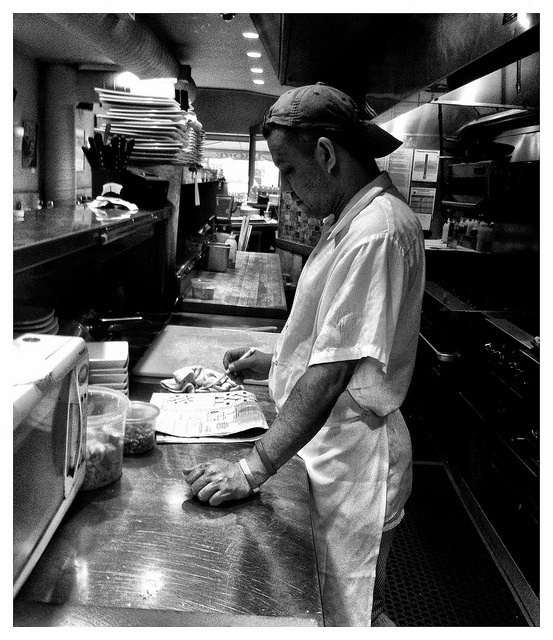Describe the objects in this image and their specific colors. I can see people in white, darkgray, black, gray, and lightgray tones, oven in white, black, gray, darkgray, and lightgray tones, microwave in white, gray, black, and darkgray tones, bowl in white, darkgray, gray, lightgray, and black tones, and bowl in white, black, darkgray, gray, and lightgray tones in this image. 